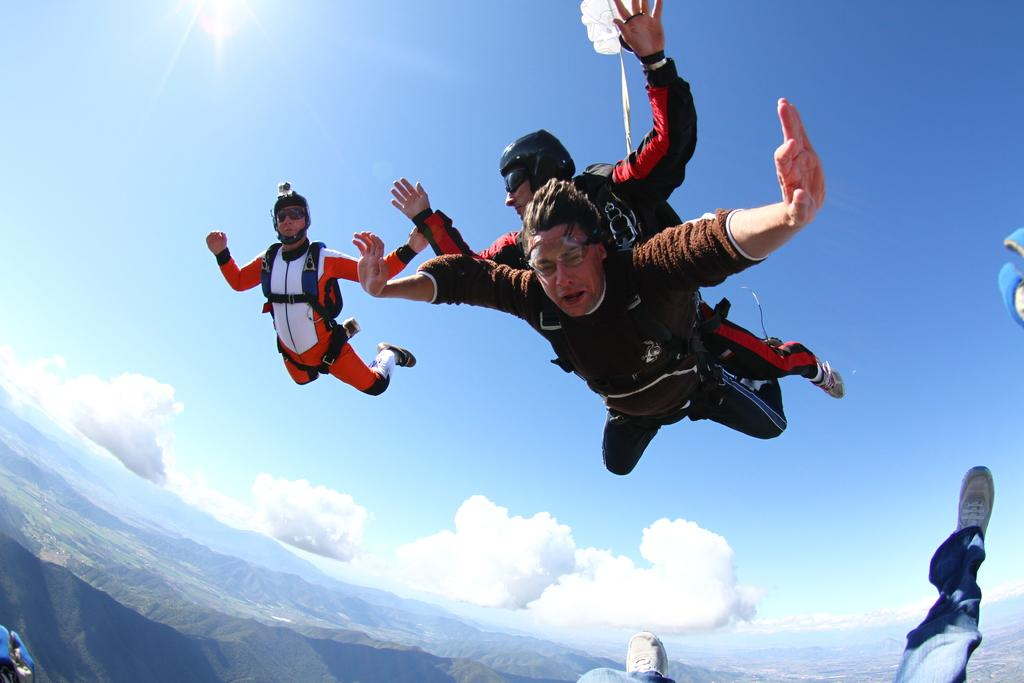What activity are the people in the image participating in? The people in the image are skydiving. Where is the skydiving taking place? The skydiving is taking place in the air. What type of landscape can be seen in the image? Hills are visible in the image. What is visible in the background of the image? The sky is visible in the image, and clouds are present in the sky. What design can be seen on the parachute of the person in the image? There is no specific design mentioned on the parachute in the image; only the activity of skydiving is described. 